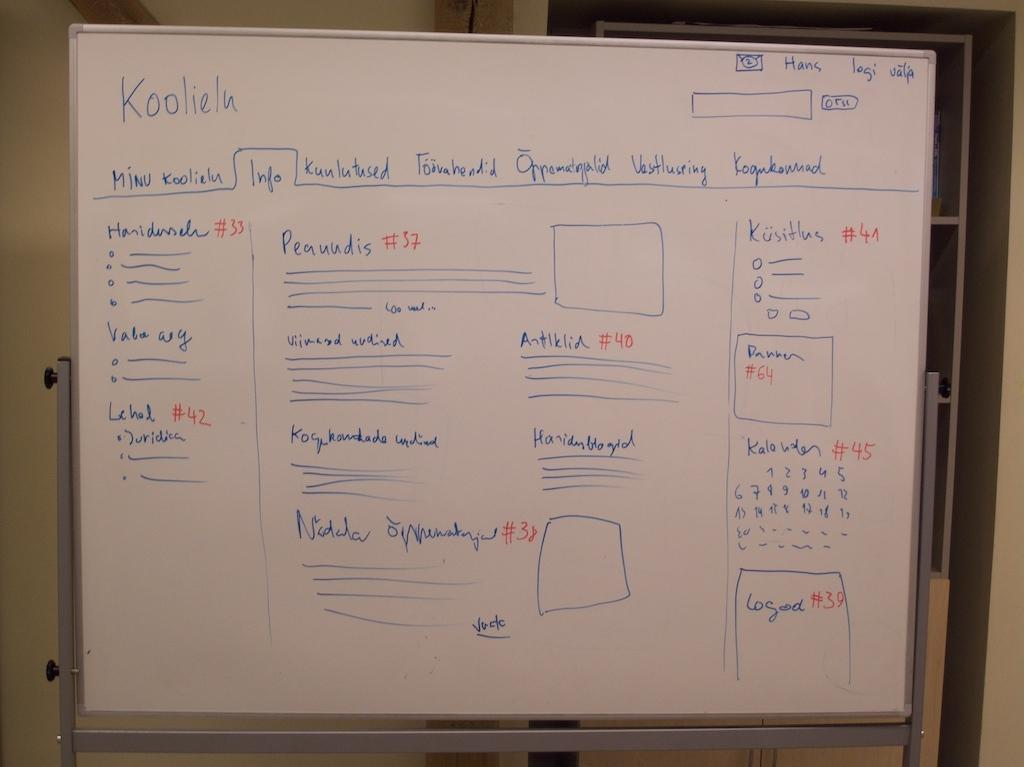<image>
Create a compact narrative representing the image presented. Koolielu is written at the top of the whiteboard. 